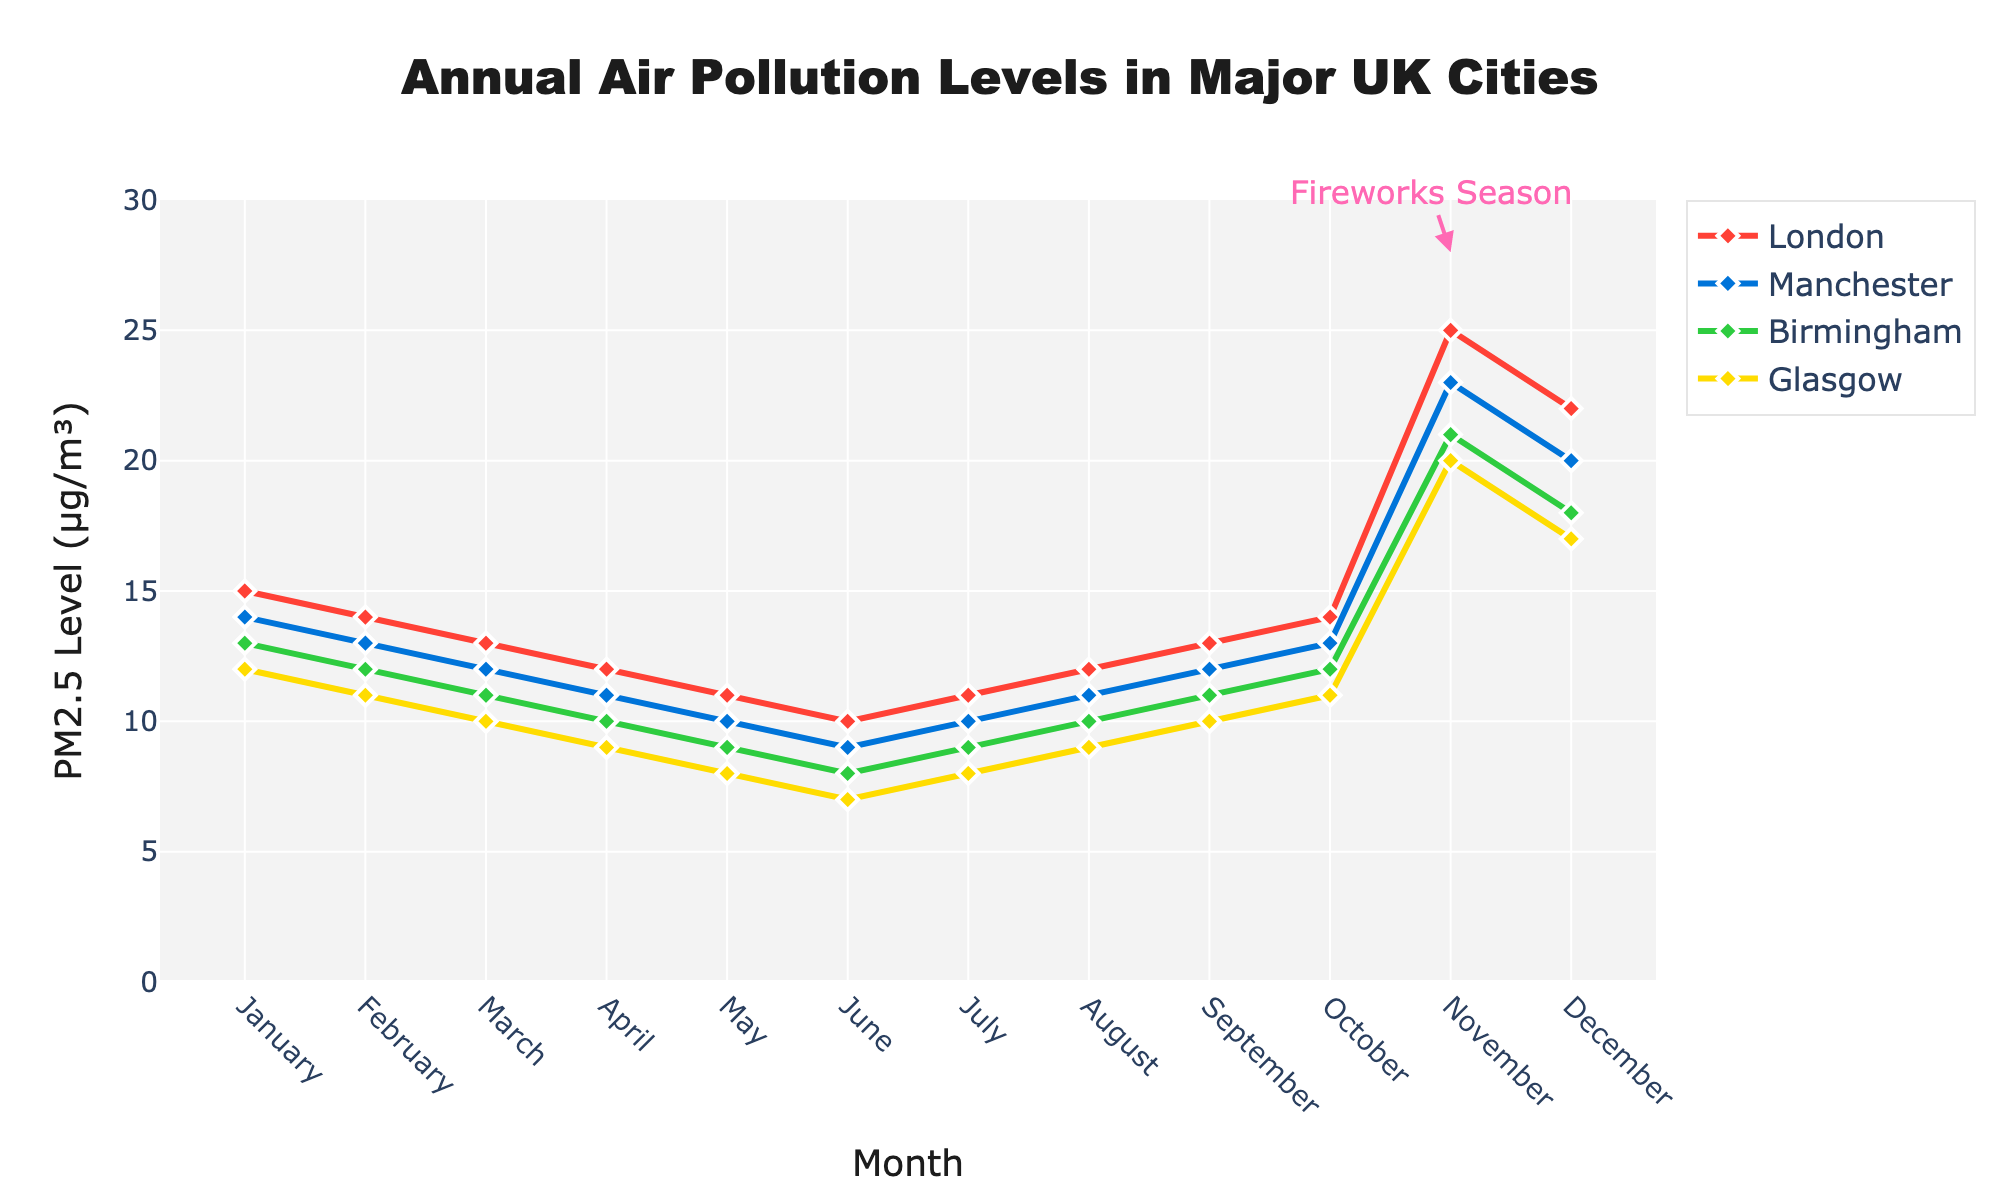What's the average PM2.5 level in London for January and February? The PM2.5 levels in London for January and February are 15 µg/m³ and 14 µg/m³, respectively. So, the average is (15 + 14) / 2 = 14.5 µg/m³
Answer: 14.5 µg/m³ How does the PM2.5 level in November compare to October in Manchester? The PM2.5 level in Manchester is 13 µg/m³ in October and 23 µg/m³ in November. Therefore, the level in November is higher by 10 µg/m³.
Answer: 10 µg/m³ higher Which city has the lowest PM2.5 level in June? The PM2.5 levels in June are 10 µg/m³ (London), 9 µg/m³ (Manchester), 8 µg/m³ (Birmingham), and 7 µg/m³ (Glasgow). Therefore, Glasgow has the lowest level in June.
Answer: Glasgow What is the difference in PM2.5 levels between December and July in Birmingham? In Birmingham, the PM2.5 level is 9 µg/m³ in July and 18 µg/m³ in December. The difference is 18 - 9 = 9 µg/m³.
Answer: 9 µg/m³ What color represents the data for Birmingham? The color used for Birmingham's data line is green. We can see this by referencing the green line in the figure which correlates with the legend for Birmingham.
Answer: Green 